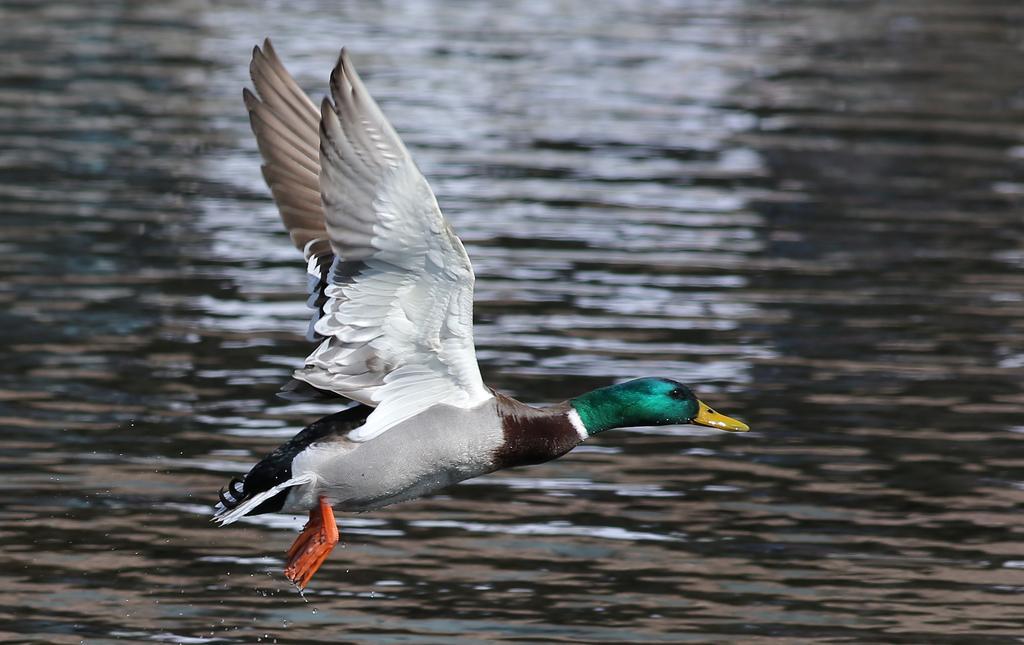In one or two sentences, can you explain what this image depicts? This picture shows a bird flying. it is black white, green in color and we see water. 